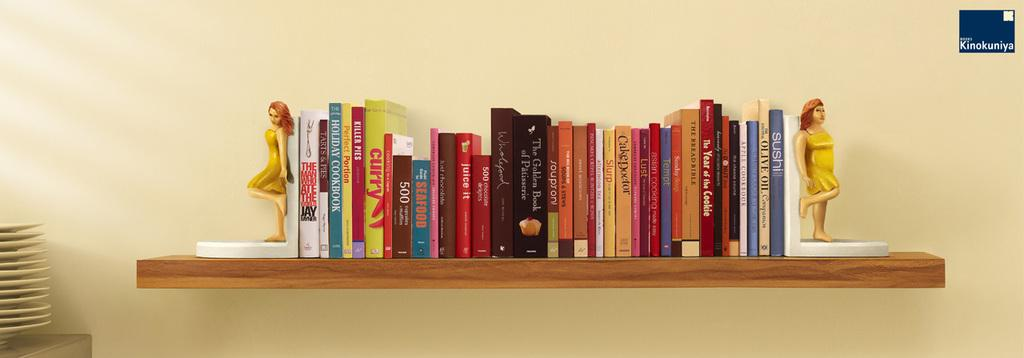Provide a one-sentence caption for the provided image. A shelf filled with cookbooks with one titled Holiday Cookbook. 